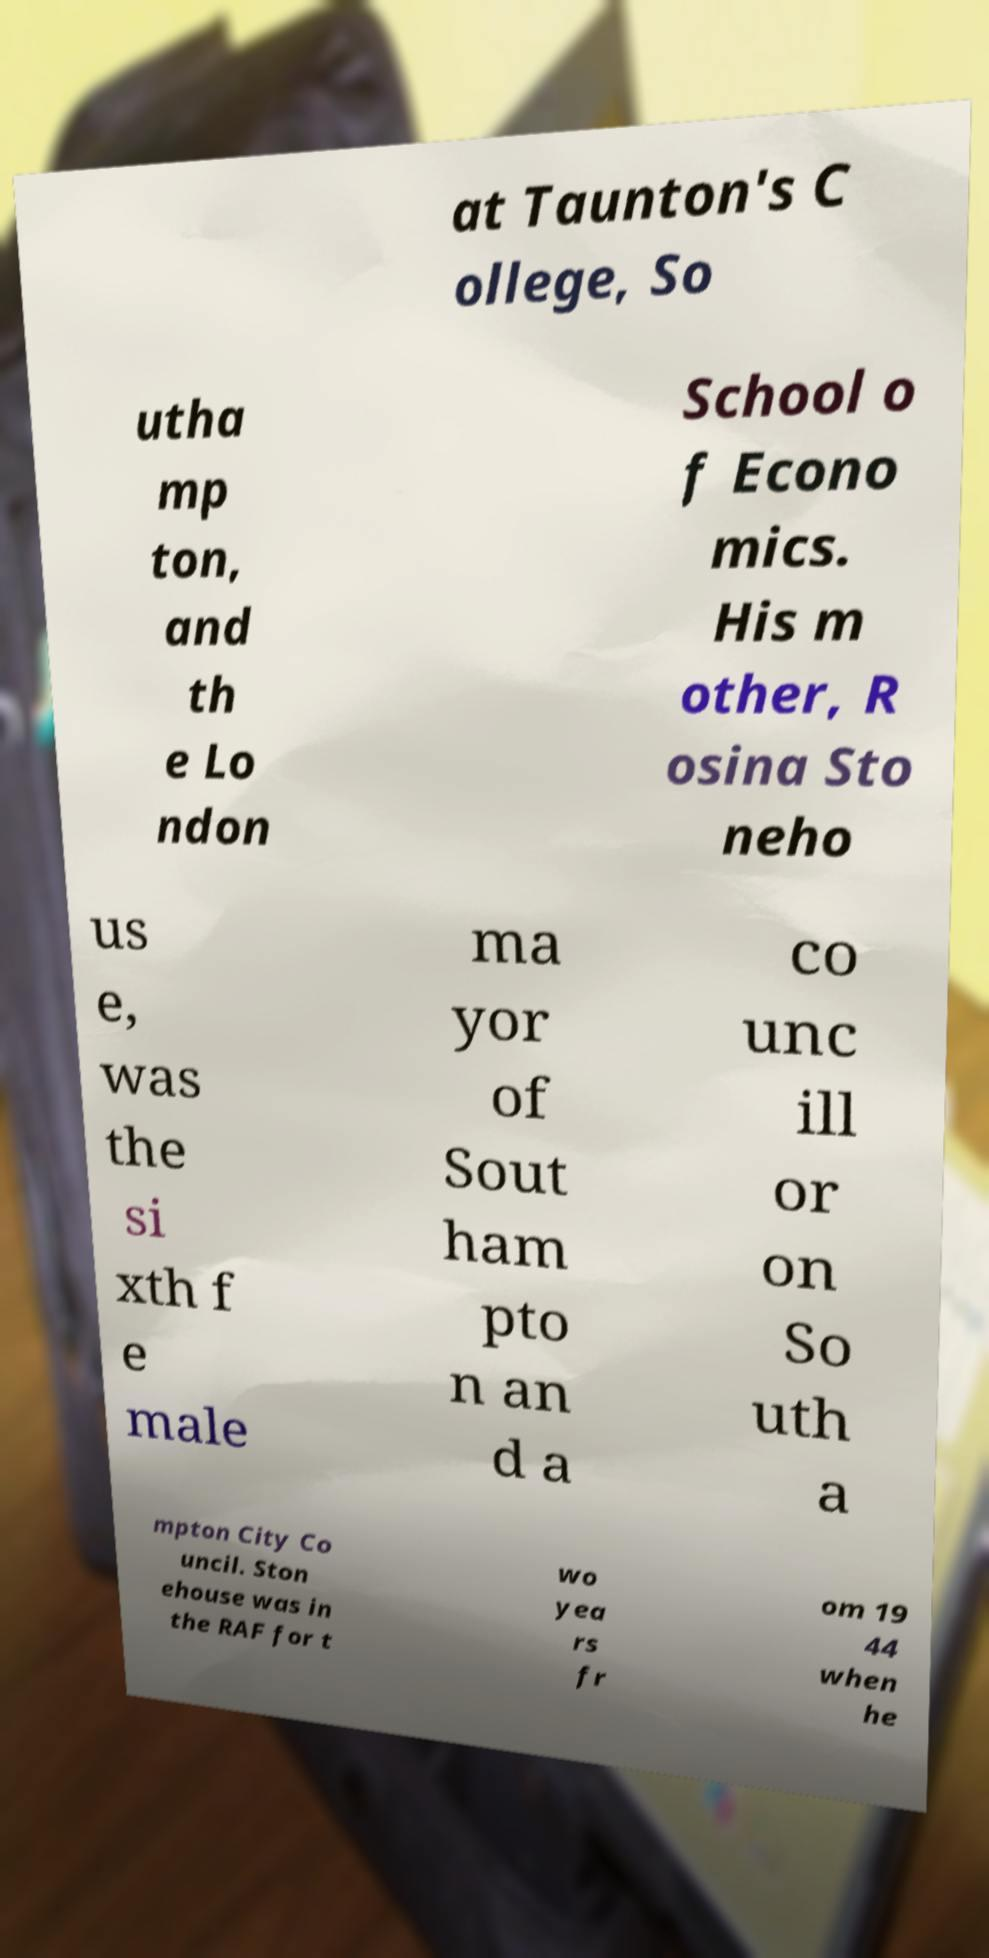Could you extract and type out the text from this image? at Taunton's C ollege, So utha mp ton, and th e Lo ndon School o f Econo mics. His m other, R osina Sto neho us e, was the si xth f e male ma yor of Sout ham pto n an d a co unc ill or on So uth a mpton City Co uncil. Ston ehouse was in the RAF for t wo yea rs fr om 19 44 when he 